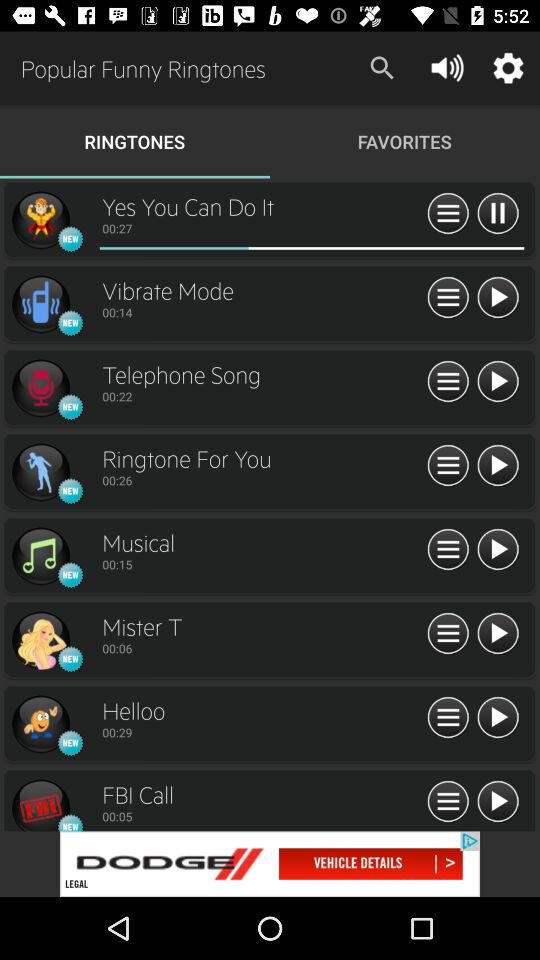How much of the selected ringtone has been finished?
When the provided information is insufficient, respond with <no answer>. <no answer> 